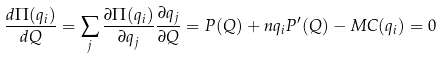Convert formula to latex. <formula><loc_0><loc_0><loc_500><loc_500>\frac { d \Pi ( q _ { i } ) } { d Q } = \sum _ { j } \frac { \partial \Pi ( q _ { i } ) } { \partial q _ { j } } \frac { \partial q _ { j } } { \partial Q } = P ( Q ) + n q _ { i } P ^ { \prime } ( Q ) - M C ( q _ { i } ) = 0</formula> 